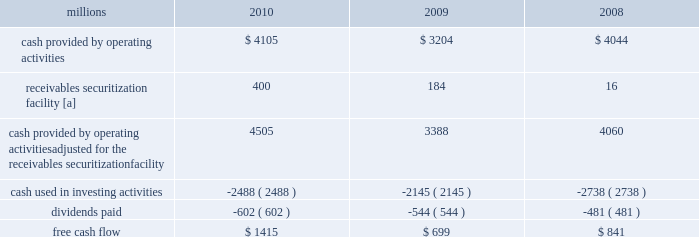2009 levels , we returned a portion of these assets to active service .
At the end of 2010 , we continued to maintain in storage approximately 17% ( 17 % ) of our multiple purpose locomotives and 14% ( 14 % ) of our freight car inventory , reflecting our ability to effectively leverage our assets as volumes return to our network .
2022 fuel prices 2013 fuel prices generally increased throughout 2010 as the economy improved .
Our average diesel fuel price per gallon increased nearly 20% ( 20 % ) from january to december of 2010 , driven by higher crude oil barrel prices and conversion spreads .
Compared to 2009 , our diesel fuel price per gallon consumed increased 31% ( 31 % ) , driving operating expenses up by $ 566 million ( excluding any impact from year-over-year volume increases ) .
To partially offset the effect of higher fuel prices , we reduced our consumption rate by 3% ( 3 % ) during the year , saving approximately 27 million gallons of fuel .
The use of newer , more fuel efficient locomotives ; increased use of distributed locomotive power ( the practice of distributing locomotives throughout a train rather than positioning them all in the lead resulting in safer and more efficient train operations ) ; fuel conservation programs ; and efficient network operations and asset utilization all contributed to this improvement .
2022 free cash flow 2013 cash generated by operating activities ( adjusted for the reclassification of our receivables securitization facility ) totaled $ 4.5 billion , yielding record free cash flow of $ 1.4 billion in 2010 .
Free cash flow is defined as cash provided by operating activities ( adjusted for the reclassification of our receivables securitization facility ) , less cash used in investing activities and dividends paid .
Free cash flow is not considered a financial measure under accounting principles generally accepted in the u.s .
( gaap ) by sec regulation g and item 10 of sec regulation s-k .
We believe free cash flow is important in evaluating our financial performance and measures our ability to generate cash without additional external financings .
Free cash flow should be considered in addition to , rather than as a substitute for , cash provided by operating activities .
The table reconciles cash provided by operating activities ( gaap measure ) to free cash flow ( non-gaap measure ) : millions 2010 2009 2008 .
[a] effective january 1 , 2010 , a new accounting standard required us to account for receivables transferred under our receivables securitization facility as secured borrowings in our consolidated statements of financial position and as financing activities in our consolidated statements of cash flows .
The receivables securitization facility is included in our free cash flow calculation to adjust cash provided by operating activities as though our receivables securitization facility had been accounted for under the new accounting standard for all periods presented .
2011 outlook 2022 safety 2013 operating a safe railroad benefits our employees , our customers , our shareholders , and the public .
We will continue using a multi-faceted approach to safety , utilizing technology , risk assessment , quality control , and training , and engaging our employees .
We will continue implementing total safety culture ( tsc ) throughout our operations .
Tsc is designed to establish , maintain , reinforce , and promote safe practices among co-workers .
This process allows us to identify and implement best practices for employee and operational safety .
Reducing grade crossing incidents is a critical aspect of our safety programs , and we will continue our efforts to maintain and close crossings ; install video cameras on locomotives ; and educate the public and law enforcement agencies about crossing safety through a combination of our own programs ( including risk assessment strategies ) , various industry programs , and engaging local communities .
2022 transportation plan 2013 to build upon our success in recent years , we will continue evaluating traffic flows and network logistic patterns , which can be quite dynamic , to identify additional opportunities to simplify operations , remove network variability , and improve network efficiency and asset utilization .
We plan to adjust manpower and our locomotive and rail car fleets to meet customer needs and put .
In 2010 what was the percent of the cash provided by operations that was from receivables securitization facility? 
Computations: (400 / 4505)
Answer: 0.08879. 2009 levels , we returned a portion of these assets to active service .
At the end of 2010 , we continued to maintain in storage approximately 17% ( 17 % ) of our multiple purpose locomotives and 14% ( 14 % ) of our freight car inventory , reflecting our ability to effectively leverage our assets as volumes return to our network .
2022 fuel prices 2013 fuel prices generally increased throughout 2010 as the economy improved .
Our average diesel fuel price per gallon increased nearly 20% ( 20 % ) from january to december of 2010 , driven by higher crude oil barrel prices and conversion spreads .
Compared to 2009 , our diesel fuel price per gallon consumed increased 31% ( 31 % ) , driving operating expenses up by $ 566 million ( excluding any impact from year-over-year volume increases ) .
To partially offset the effect of higher fuel prices , we reduced our consumption rate by 3% ( 3 % ) during the year , saving approximately 27 million gallons of fuel .
The use of newer , more fuel efficient locomotives ; increased use of distributed locomotive power ( the practice of distributing locomotives throughout a train rather than positioning them all in the lead resulting in safer and more efficient train operations ) ; fuel conservation programs ; and efficient network operations and asset utilization all contributed to this improvement .
2022 free cash flow 2013 cash generated by operating activities ( adjusted for the reclassification of our receivables securitization facility ) totaled $ 4.5 billion , yielding record free cash flow of $ 1.4 billion in 2010 .
Free cash flow is defined as cash provided by operating activities ( adjusted for the reclassification of our receivables securitization facility ) , less cash used in investing activities and dividends paid .
Free cash flow is not considered a financial measure under accounting principles generally accepted in the u.s .
( gaap ) by sec regulation g and item 10 of sec regulation s-k .
We believe free cash flow is important in evaluating our financial performance and measures our ability to generate cash without additional external financings .
Free cash flow should be considered in addition to , rather than as a substitute for , cash provided by operating activities .
The table reconciles cash provided by operating activities ( gaap measure ) to free cash flow ( non-gaap measure ) : millions 2010 2009 2008 .
[a] effective january 1 , 2010 , a new accounting standard required us to account for receivables transferred under our receivables securitization facility as secured borrowings in our consolidated statements of financial position and as financing activities in our consolidated statements of cash flows .
The receivables securitization facility is included in our free cash flow calculation to adjust cash provided by operating activities as though our receivables securitization facility had been accounted for under the new accounting standard for all periods presented .
2011 outlook 2022 safety 2013 operating a safe railroad benefits our employees , our customers , our shareholders , and the public .
We will continue using a multi-faceted approach to safety , utilizing technology , risk assessment , quality control , and training , and engaging our employees .
We will continue implementing total safety culture ( tsc ) throughout our operations .
Tsc is designed to establish , maintain , reinforce , and promote safe practices among co-workers .
This process allows us to identify and implement best practices for employee and operational safety .
Reducing grade crossing incidents is a critical aspect of our safety programs , and we will continue our efforts to maintain and close crossings ; install video cameras on locomotives ; and educate the public and law enforcement agencies about crossing safety through a combination of our own programs ( including risk assessment strategies ) , various industry programs , and engaging local communities .
2022 transportation plan 2013 to build upon our success in recent years , we will continue evaluating traffic flows and network logistic patterns , which can be quite dynamic , to identify additional opportunities to simplify operations , remove network variability , and improve network efficiency and asset utilization .
We plan to adjust manpower and our locomotive and rail car fleets to meet customer needs and put .
What is the mathematical range , in millions , for total free cash flow from 2008-2010? 
Computations: (1415 - 699)
Answer: 716.0. 